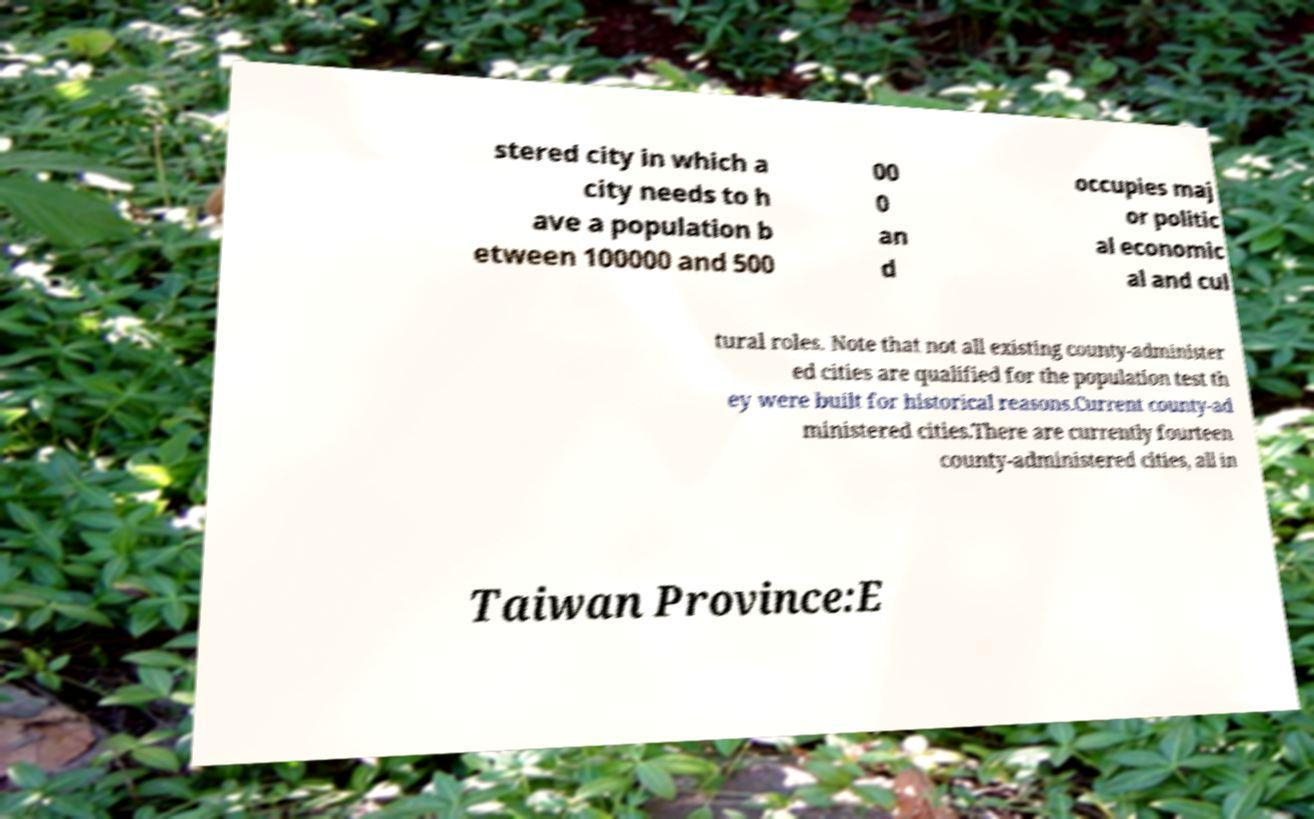Could you assist in decoding the text presented in this image and type it out clearly? stered city in which a city needs to h ave a population b etween 100000 and 500 00 0 an d occupies maj or politic al economic al and cul tural roles. Note that not all existing county-administer ed cities are qualified for the population test th ey were built for historical reasons.Current county-ad ministered cities.There are currently fourteen county-administered cities, all in Taiwan Province:E 